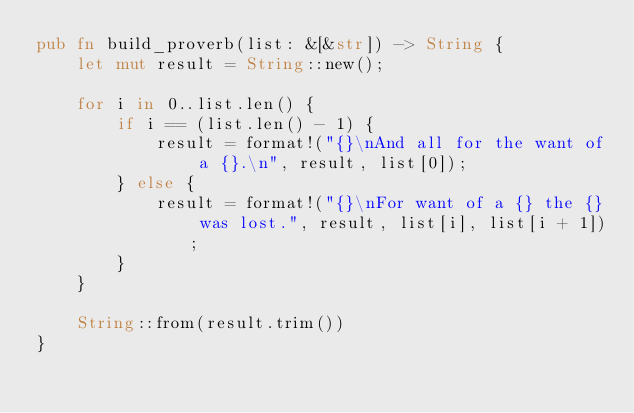<code> <loc_0><loc_0><loc_500><loc_500><_Rust_>pub fn build_proverb(list: &[&str]) -> String {
    let mut result = String::new();

    for i in 0..list.len() {
        if i == (list.len() - 1) {
            result = format!("{}\nAnd all for the want of a {}.\n", result, list[0]);
        } else {
            result = format!("{}\nFor want of a {} the {} was lost.", result, list[i], list[i + 1]);
        }
    }

    String::from(result.trim())
}
</code> 